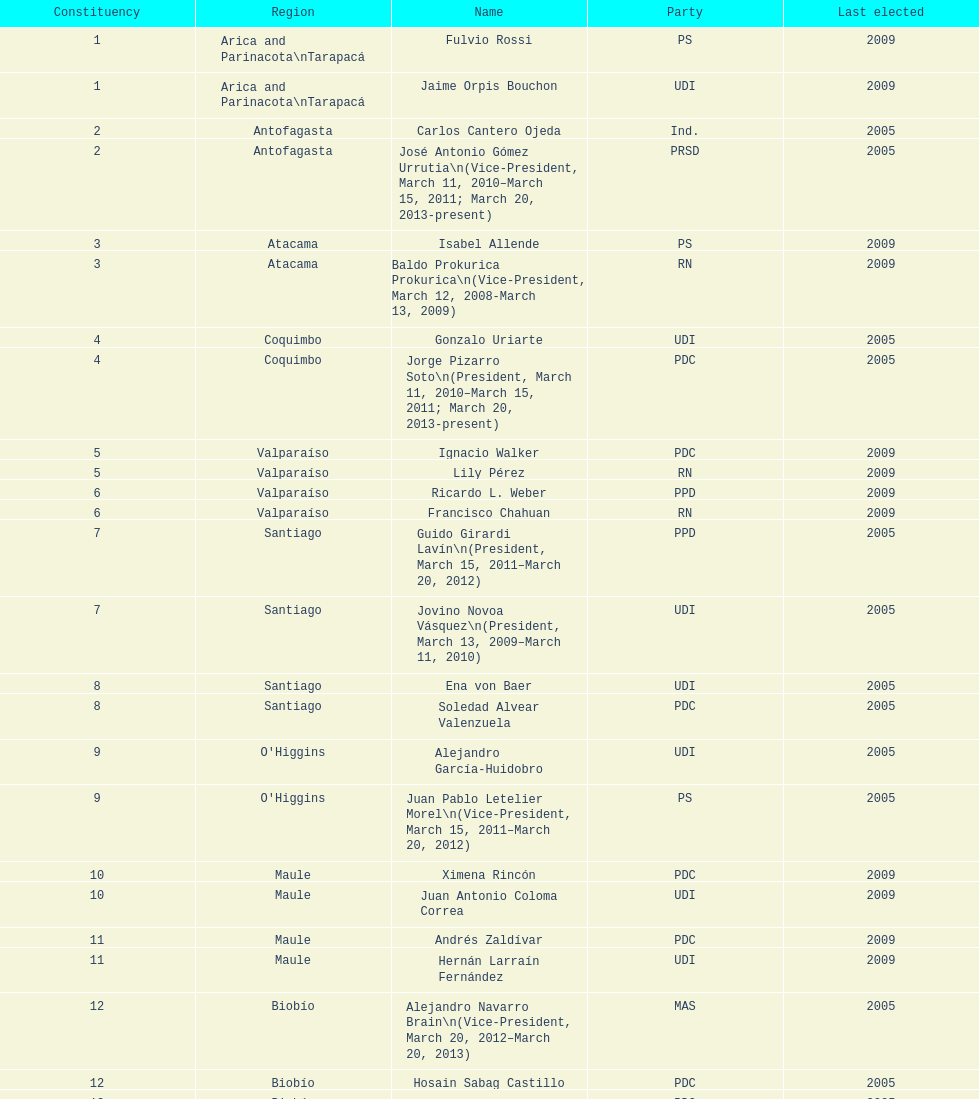What is the total number of constituencies listed in the table? 19. 